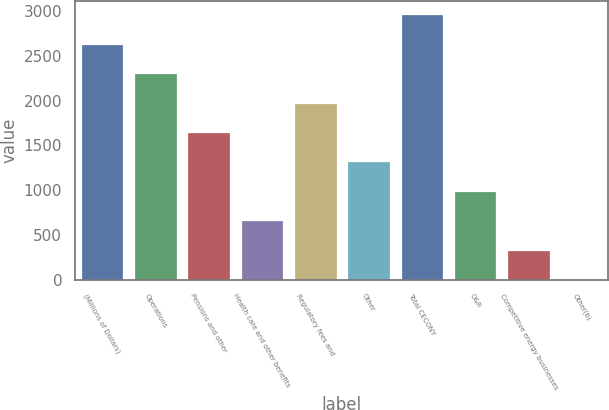Convert chart. <chart><loc_0><loc_0><loc_500><loc_500><bar_chart><fcel>(Millions of Dollars)<fcel>Operations<fcel>Pensions and other<fcel>Health care and other benefits<fcel>Regulatory fees and<fcel>Other<fcel>Total CECONY<fcel>O&R<fcel>Competitive energy businesses<fcel>Other(b)<nl><fcel>2636.2<fcel>2307.3<fcel>1649.5<fcel>662.8<fcel>1978.4<fcel>1320.6<fcel>2965.1<fcel>991.7<fcel>333.9<fcel>5<nl></chart> 